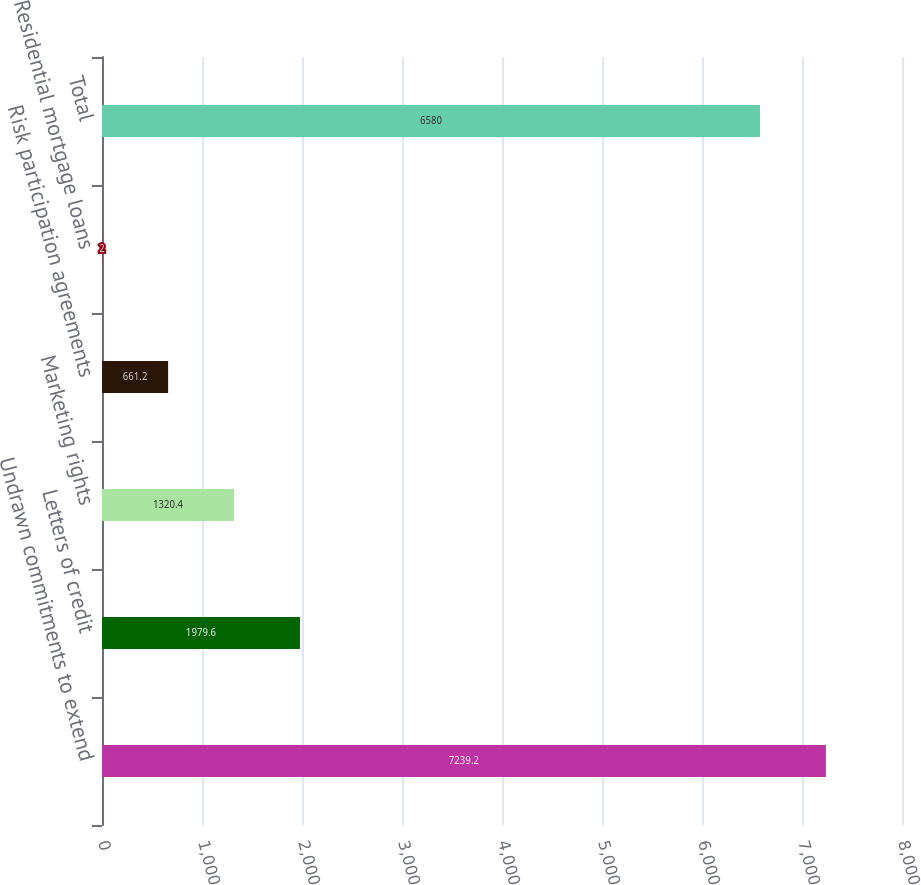Convert chart. <chart><loc_0><loc_0><loc_500><loc_500><bar_chart><fcel>Undrawn commitments to extend<fcel>Letters of credit<fcel>Marketing rights<fcel>Risk participation agreements<fcel>Residential mortgage loans<fcel>Total<nl><fcel>7239.2<fcel>1979.6<fcel>1320.4<fcel>661.2<fcel>2<fcel>6580<nl></chart> 